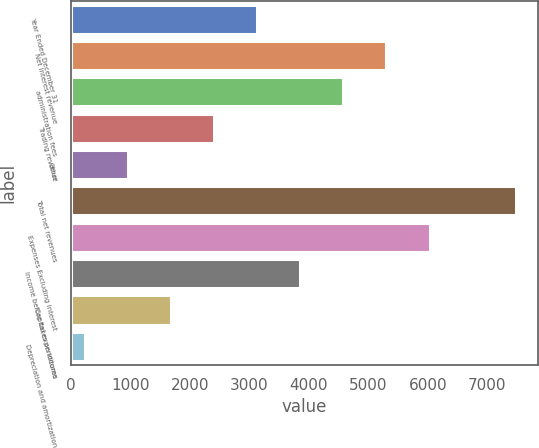<chart> <loc_0><loc_0><loc_500><loc_500><bar_chart><fcel>Year Ended December 31<fcel>Net interest revenue<fcel>administration fees<fcel>Trading revenue<fcel>Other<fcel>Total net revenues<fcel>Expenses Excluding Interest<fcel>Income before taxes on income<fcel>Capital expenditures<fcel>Depreciation and amortization<nl><fcel>3131.6<fcel>5304.8<fcel>4580.4<fcel>2407.2<fcel>958.4<fcel>7478<fcel>6029.2<fcel>3856<fcel>1682.8<fcel>234<nl></chart> 